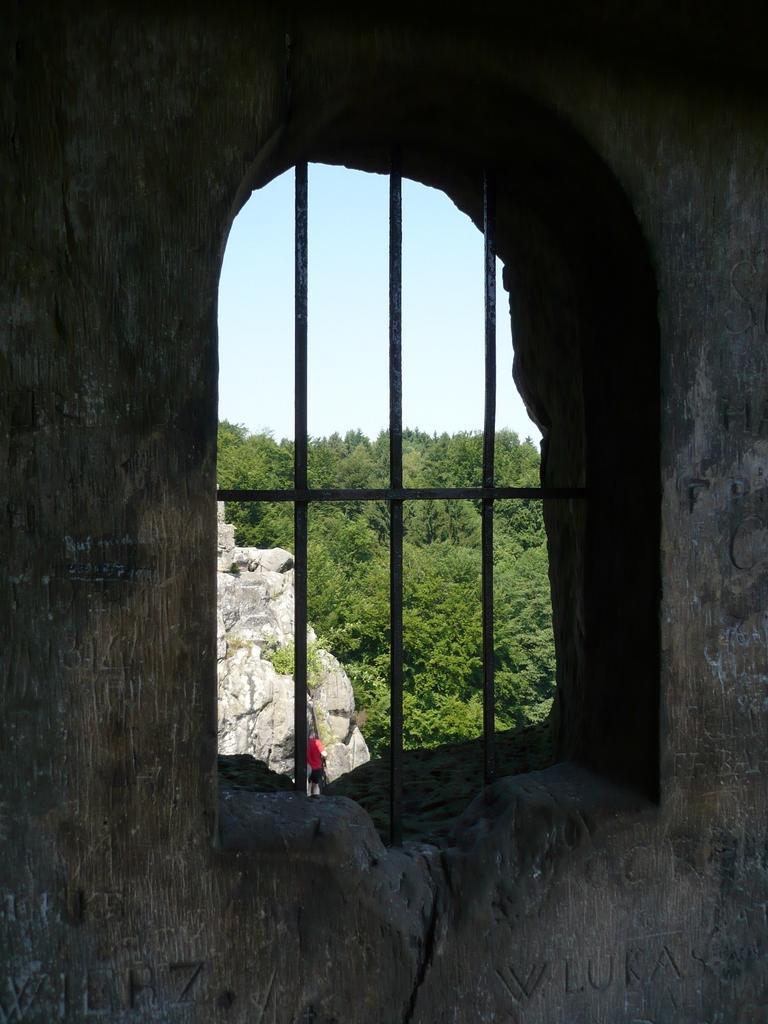What can be seen in the image that provides a view of the outdoors? There is a window in the image. Can you describe the man visible in the background of the image? There is a man visible in the background of the image, but no specific details about him are provided. What type of vegetation is visible in the background of the image? There are green color trees in the background of the image. What type of badge is the man wearing in the image? There is no man wearing a badge in the image, as the man's attire is not described in the provided facts. 